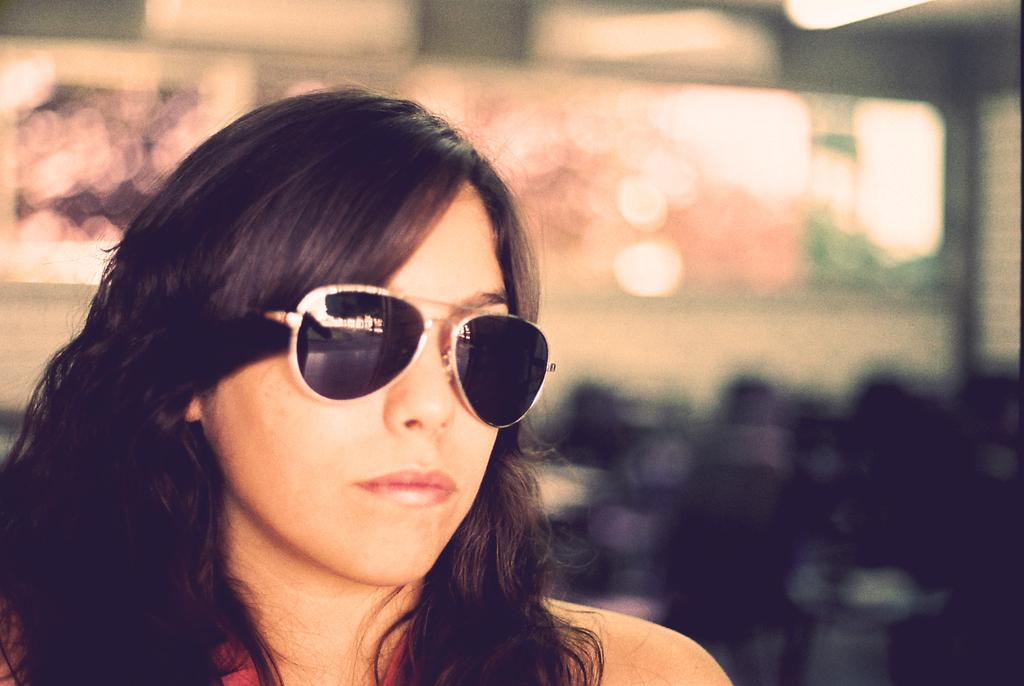Who is the main subject in the image? There is a woman in the image. What is the woman wearing in the image? The woman is wearing spectacles in the image. Can you describe the background of the image? The background of the image is blurred. What type of polish is the woman applying to her nails in the image? There is no indication in the image that the woman is applying any polish to her nails. 